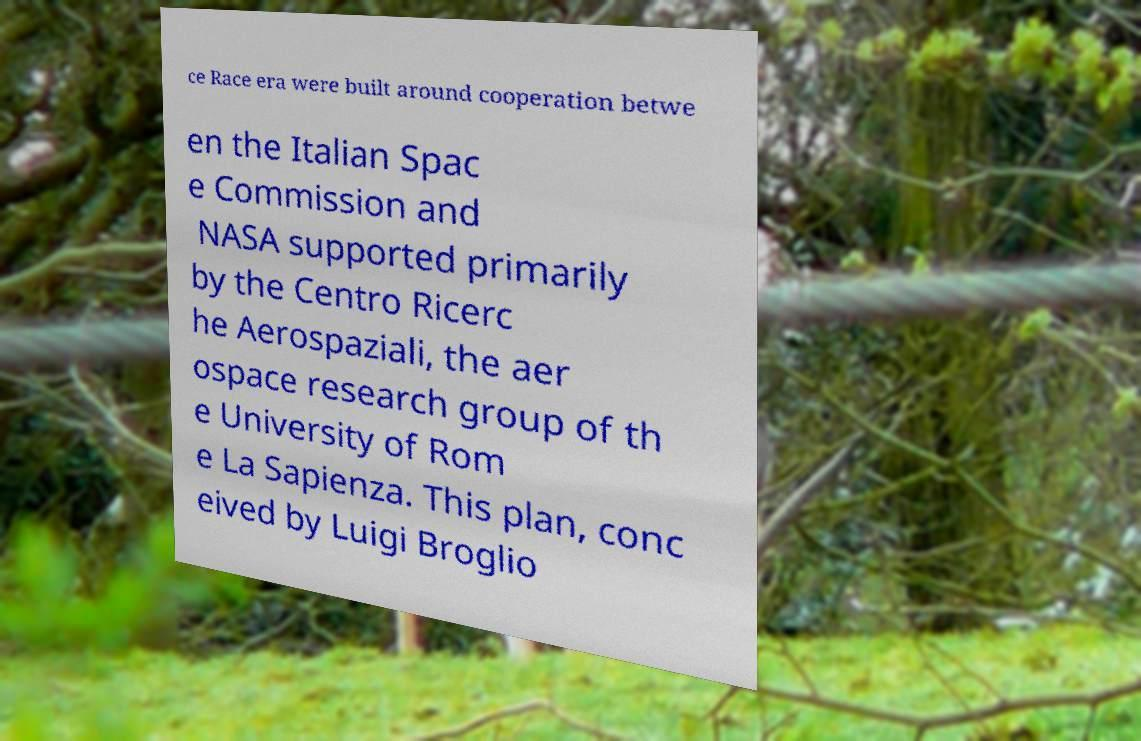Please read and relay the text visible in this image. What does it say? ce Race era were built around cooperation betwe en the Italian Spac e Commission and NASA supported primarily by the Centro Ricerc he Aerospaziali, the aer ospace research group of th e University of Rom e La Sapienza. This plan, conc eived by Luigi Broglio 